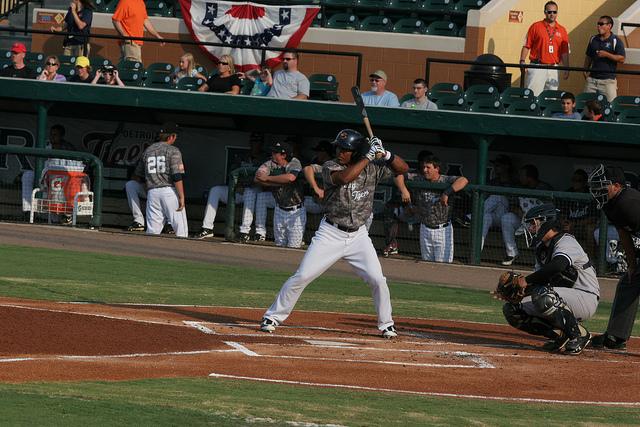What sport are they playing?
Be succinct. Baseball. What kind of outfit is the man wearing?
Answer briefly. Baseball uniform. What pattern is the batters Jersey?
Write a very short answer. Camouflage. What is the batters foot on?
Answer briefly. Dirt. Does he have the ball?
Answer briefly. No. Is the batter left or right handed?
Keep it brief. Left. Who is behind the batter?
Write a very short answer. Catcher. How many sunglasses are shown?
Answer briefly. 7. 